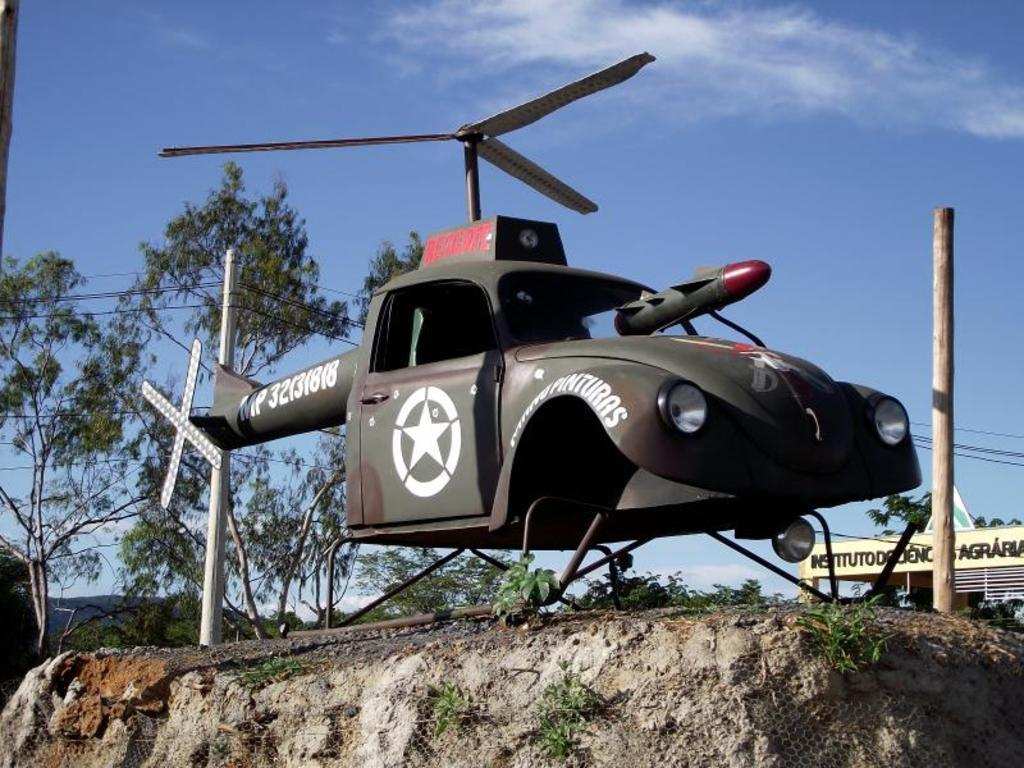What is the main subject of the image? The main subject of the image is a model of a helicopter. Are there any details on the helicopter model? Yes, there is text written on the helicopter model. What can be seen in the background of the image? In the background of the image, there are trees, poles, and wires. What type of advertisement can be seen hanging from the helicopter model in the image? There is no advertisement hanging from the helicopter model in the image; it is a model of a helicopter with text written on it. Can you tell me how many lockets are visible on the helicopter model? There are no lockets present on the helicopter model in the image. 